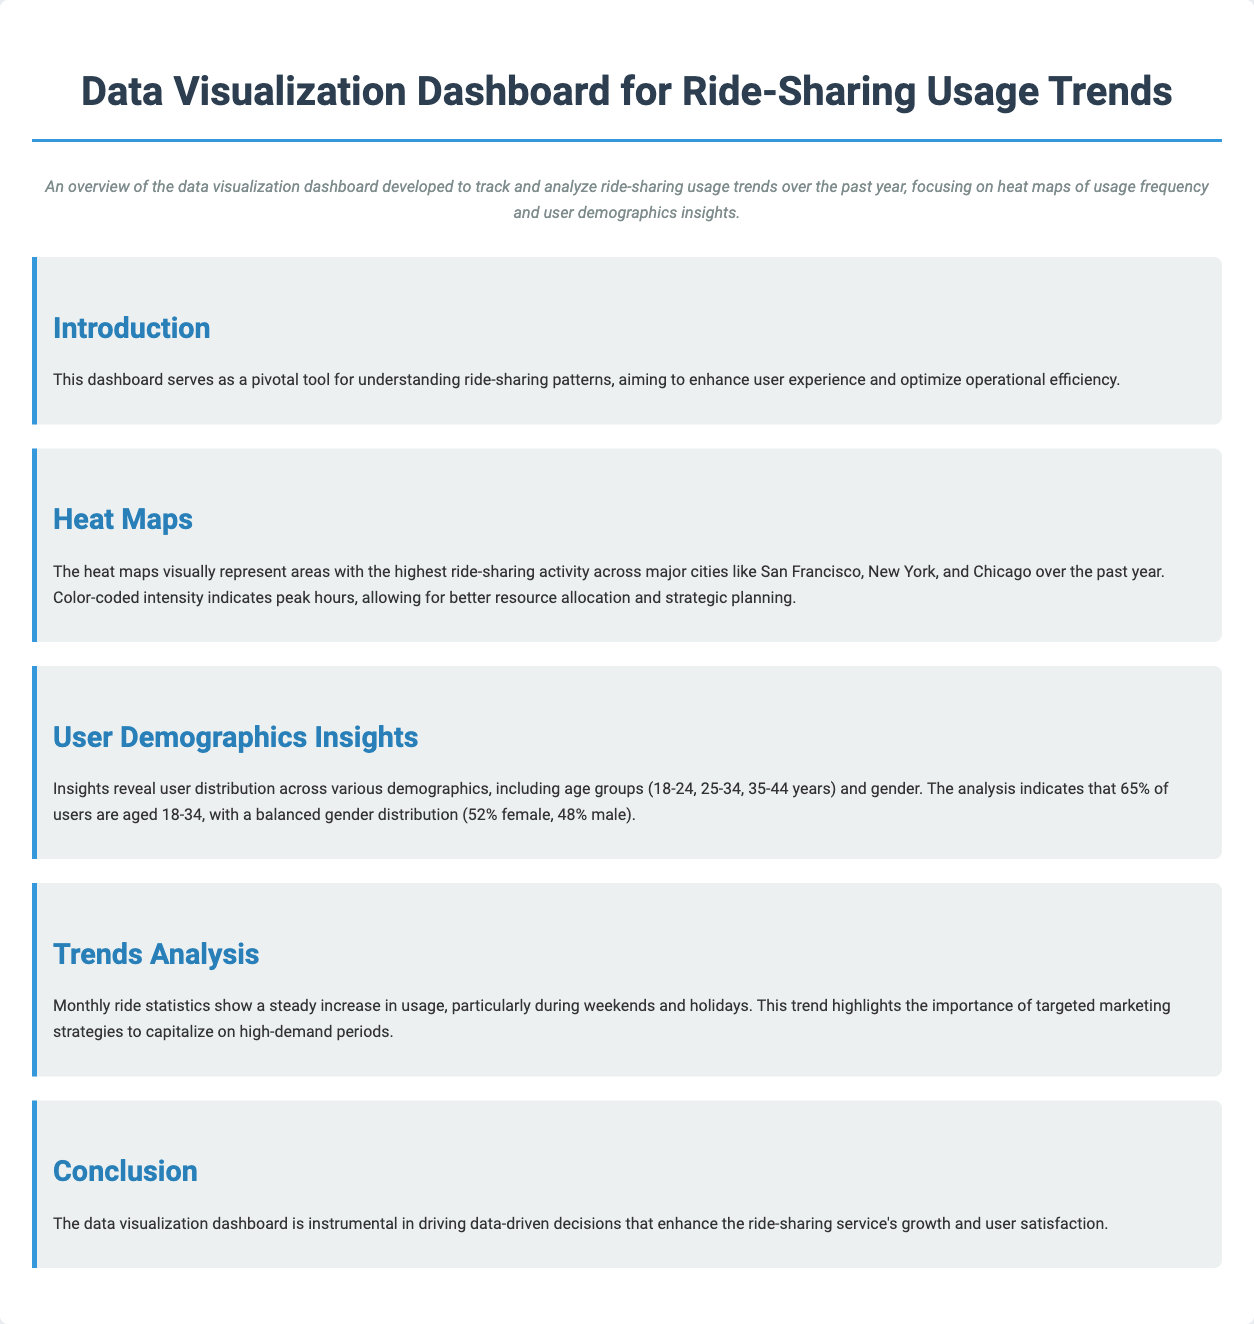What is the title of the dashboard? The title is stated prominently at the top of the document, which is "Data Visualization Dashboard for Ride-Sharing Usage Trends."
Answer: Data Visualization Dashboard for Ride-Sharing Usage Trends What cities are mentioned in the heat maps section? The document lists major cities where ride-sharing activity is observed, specifically "San Francisco, New York, and Chicago."
Answer: San Francisco, New York, Chicago What percentage of users are aged 18-34? The demographics insights section provides specific information about user age distribution, stating that "65% of users are aged 18-34."
Answer: 65% What is the gender distribution of users? The document indicates the distribution of users by gender, stating "52% female, 48% male."
Answer: 52% female, 48% male During which times is ride-sharing usage particularly high? The trends analysis mentions that ridership increases especially during "weekends and holidays."
Answer: Weekends and holidays What is the primary purpose of the dashboard? The introduction describes the dashboard's primary function, emphasizing understanding ride-sharing patterns to "enhance user experience and optimize operational efficiency."
Answer: Enhance user experience and optimize operational efficiency What color coding in the heat maps indicates? The heat maps employ color coding to indicate "peak hours," which assists in resource allocation.
Answer: Peak hours What is emphasized as crucial for marketing strategies? The trends analysis discusses the importance of targeting high-demand periods, highlighting this in connection to "targeted marketing strategies."
Answer: Targeted marketing strategies 